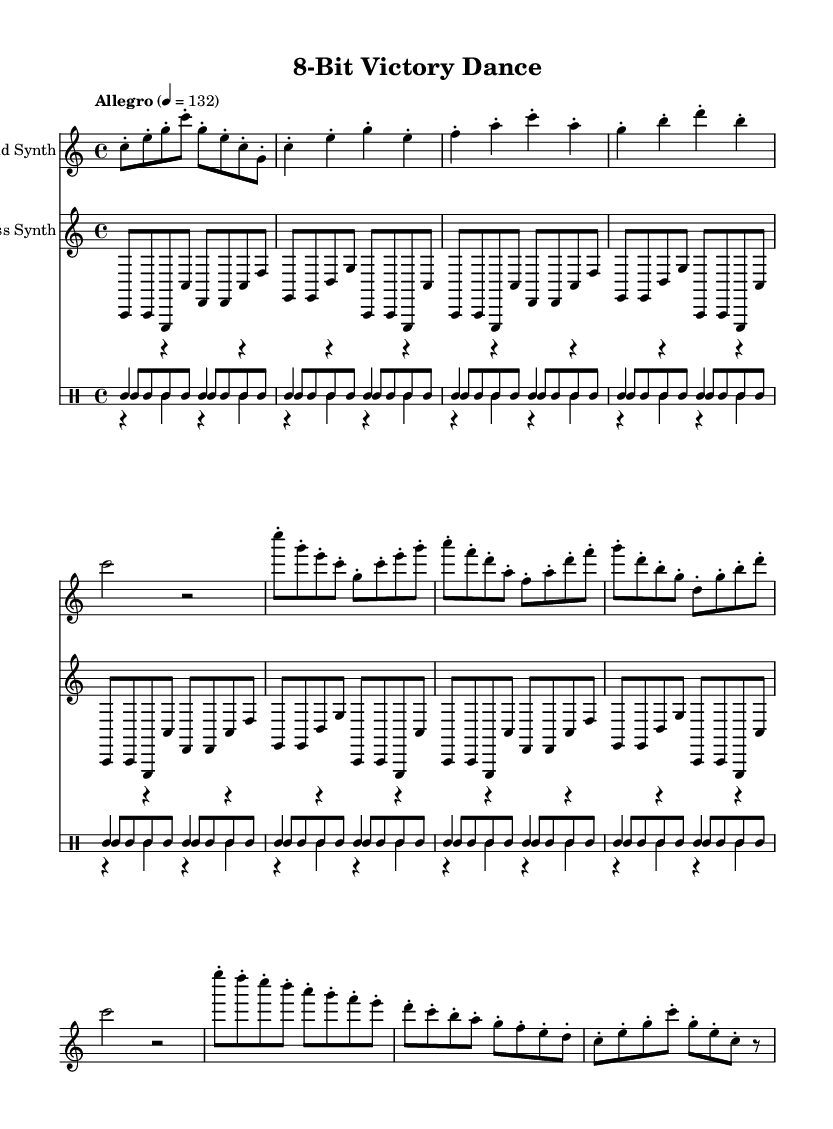What is the key signature of this music? The key signature is C major, which has no sharps or flats.
Answer: C major What is the time signature of this piece? The time signature is indicated as 4/4, meaning there are four beats per measure.
Answer: 4/4 What is the tempo marking for this piece? The tempo marking indicates "Allegro," which suggests a lively and fast-paced performance, defined here as quarter note equals 132 beats per minute.
Answer: Allegro How many measures are in the introduction? The introduction consists of 1 measure, as indicated by the brief melodic line before the verses begin.
Answer: 1 How many different voices are used in this music? The score features three distinct voices: the lead synth, bass synth, and drum parts for kick drum, snare drum, and hi-hat.
Answer: Three What pattern does the lead synth follow during the chorus? The lead synth in the chorus has a repeated melodic phrase that moves through the pitches of C, G, E, and others in an upbeat rhythmic manner, mirroring the dance-like quality.
Answer: Repeated melodic phrase Which section contains the bridge? The bridge section is identified visually by the distinct musical phrasing that introduces a contrast from the preceding sections, specifically labeled as "Bridge."
Answer: Bridge 